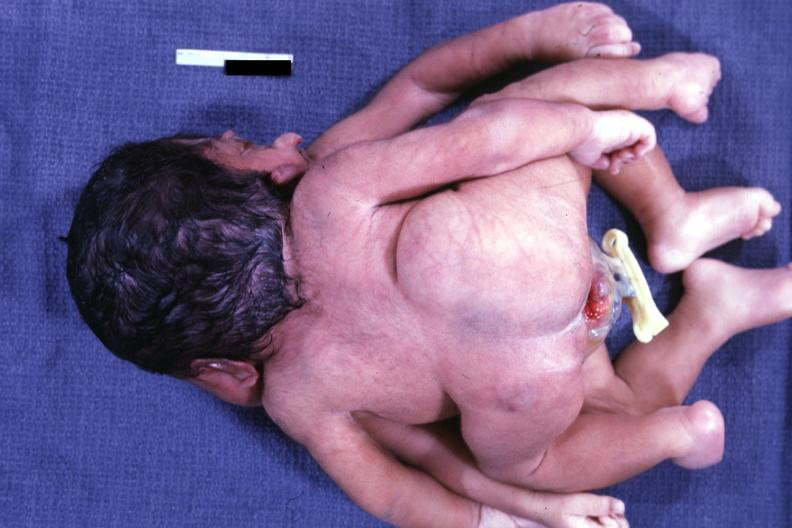s conjoined twins cephalothoracopagus janiceps present?
Answer the question using a single word or phrase. Yes 